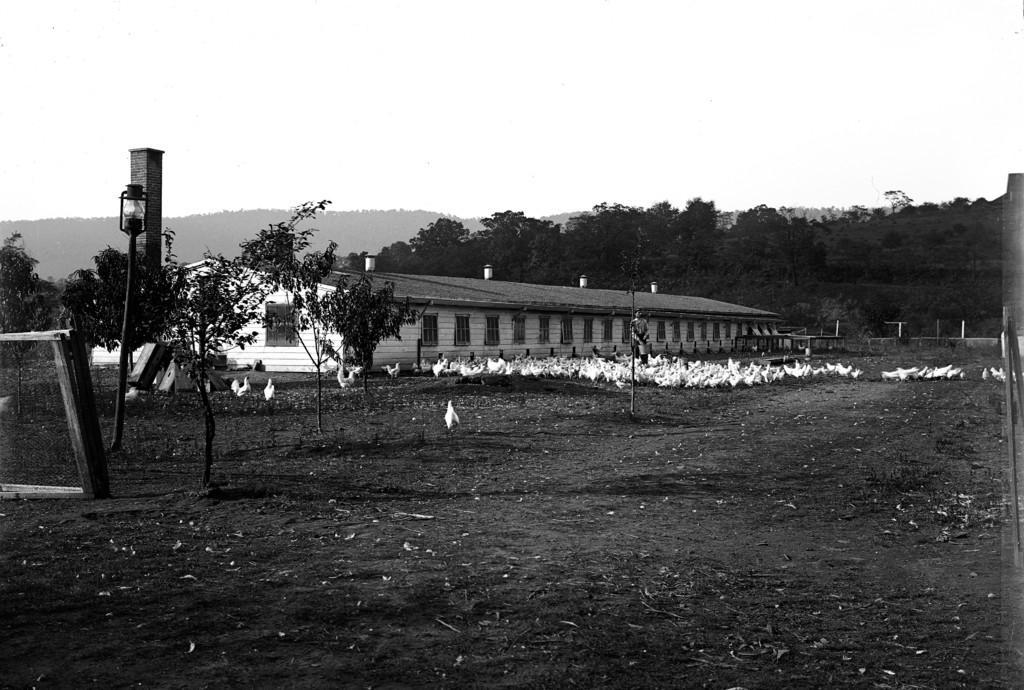How would you summarize this image in a sentence or two? In this picture we can see a person and birds on the ground, here we can see a shed, trees and some objects and we can see sky in the background. 